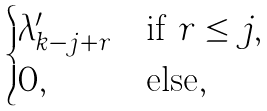Convert formula to latex. <formula><loc_0><loc_0><loc_500><loc_500>\begin{cases} \lambda ^ { \prime } _ { k - j + r } & \text {if } r \leq j , \\ 0 , & \text {else} , \end{cases}</formula> 